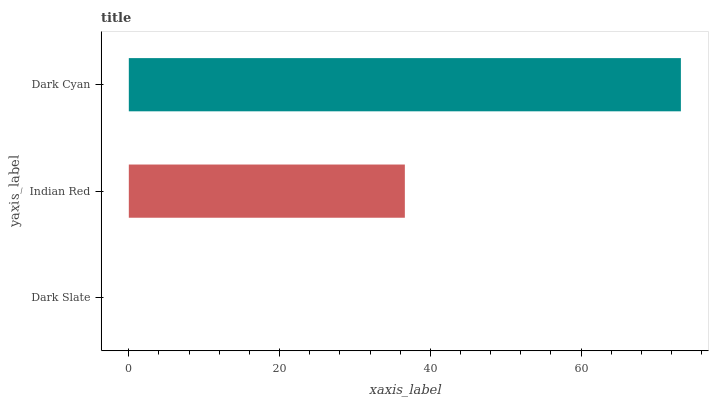Is Dark Slate the minimum?
Answer yes or no. Yes. Is Dark Cyan the maximum?
Answer yes or no. Yes. Is Indian Red the minimum?
Answer yes or no. No. Is Indian Red the maximum?
Answer yes or no. No. Is Indian Red greater than Dark Slate?
Answer yes or no. Yes. Is Dark Slate less than Indian Red?
Answer yes or no. Yes. Is Dark Slate greater than Indian Red?
Answer yes or no. No. Is Indian Red less than Dark Slate?
Answer yes or no. No. Is Indian Red the high median?
Answer yes or no. Yes. Is Indian Red the low median?
Answer yes or no. Yes. Is Dark Cyan the high median?
Answer yes or no. No. Is Dark Cyan the low median?
Answer yes or no. No. 